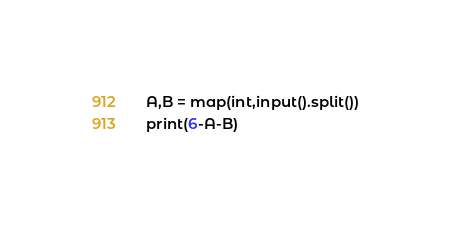Convert code to text. <code><loc_0><loc_0><loc_500><loc_500><_Python_>A,B = map(int,input().split())
print(6-A-B)</code> 